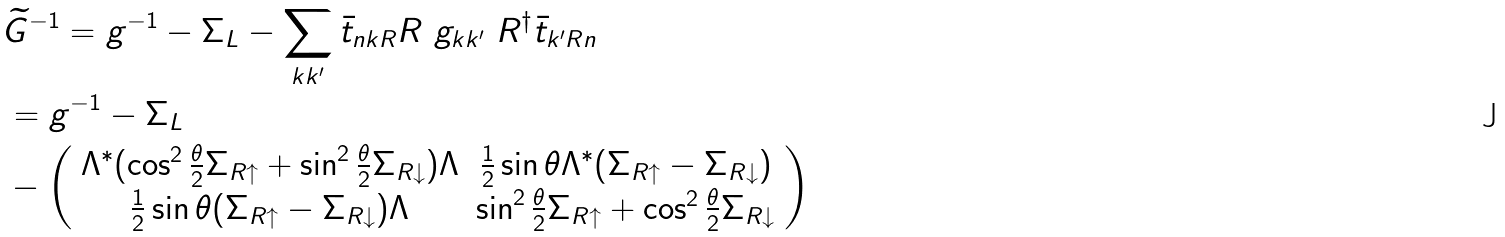<formula> <loc_0><loc_0><loc_500><loc_500>& \widetilde { G } ^ { - 1 } = g ^ { - 1 } - \Sigma _ { L } - \sum _ { k k ^ { \prime } } \bar { t } _ { n k R } R \ g _ { k k ^ { \prime } } \ R ^ { \dag } \bar { t } _ { k ^ { \prime } R n } \\ & = g ^ { - 1 } - \Sigma _ { L } \\ & - \left ( \begin{array} { c c } \Lambda ^ { * } ( \cos ^ { 2 } \frac { \theta } { 2 } \Sigma _ { R \uparrow } + \sin ^ { 2 } \frac { \theta } { 2 } \Sigma _ { R \downarrow } ) \Lambda & \frac { 1 } { 2 } \sin \theta \Lambda ^ { * } ( \Sigma _ { R \uparrow } - \Sigma _ { R \downarrow } ) \\ \frac { 1 } { 2 } \sin \theta ( \Sigma _ { R \uparrow } - \Sigma _ { R \downarrow } ) \Lambda & \sin ^ { 2 } \frac { \theta } { 2 } \Sigma _ { R \uparrow } + \cos ^ { 2 } \frac { \theta } { 2 } \Sigma _ { R \downarrow } \end{array} \right )</formula> 